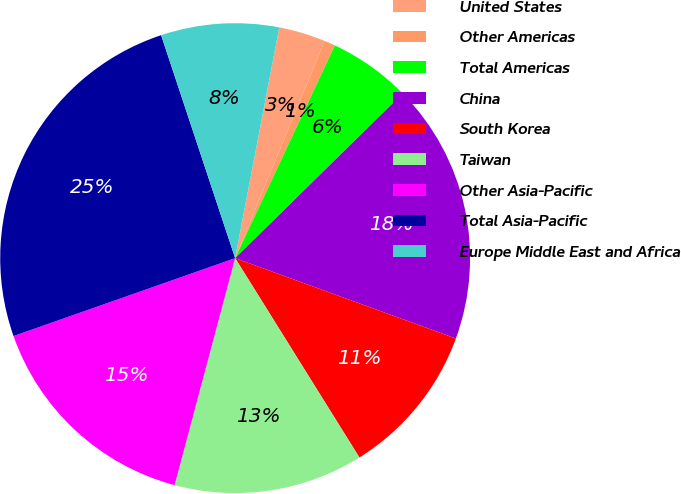Convert chart. <chart><loc_0><loc_0><loc_500><loc_500><pie_chart><fcel>United States<fcel>Other Americas<fcel>Total Americas<fcel>China<fcel>South Korea<fcel>Taiwan<fcel>Other Asia-Pacific<fcel>Total Asia-Pacific<fcel>Europe Middle East and Africa<nl><fcel>3.21%<fcel>0.76%<fcel>5.66%<fcel>17.92%<fcel>10.57%<fcel>13.02%<fcel>15.47%<fcel>25.28%<fcel>8.11%<nl></chart> 